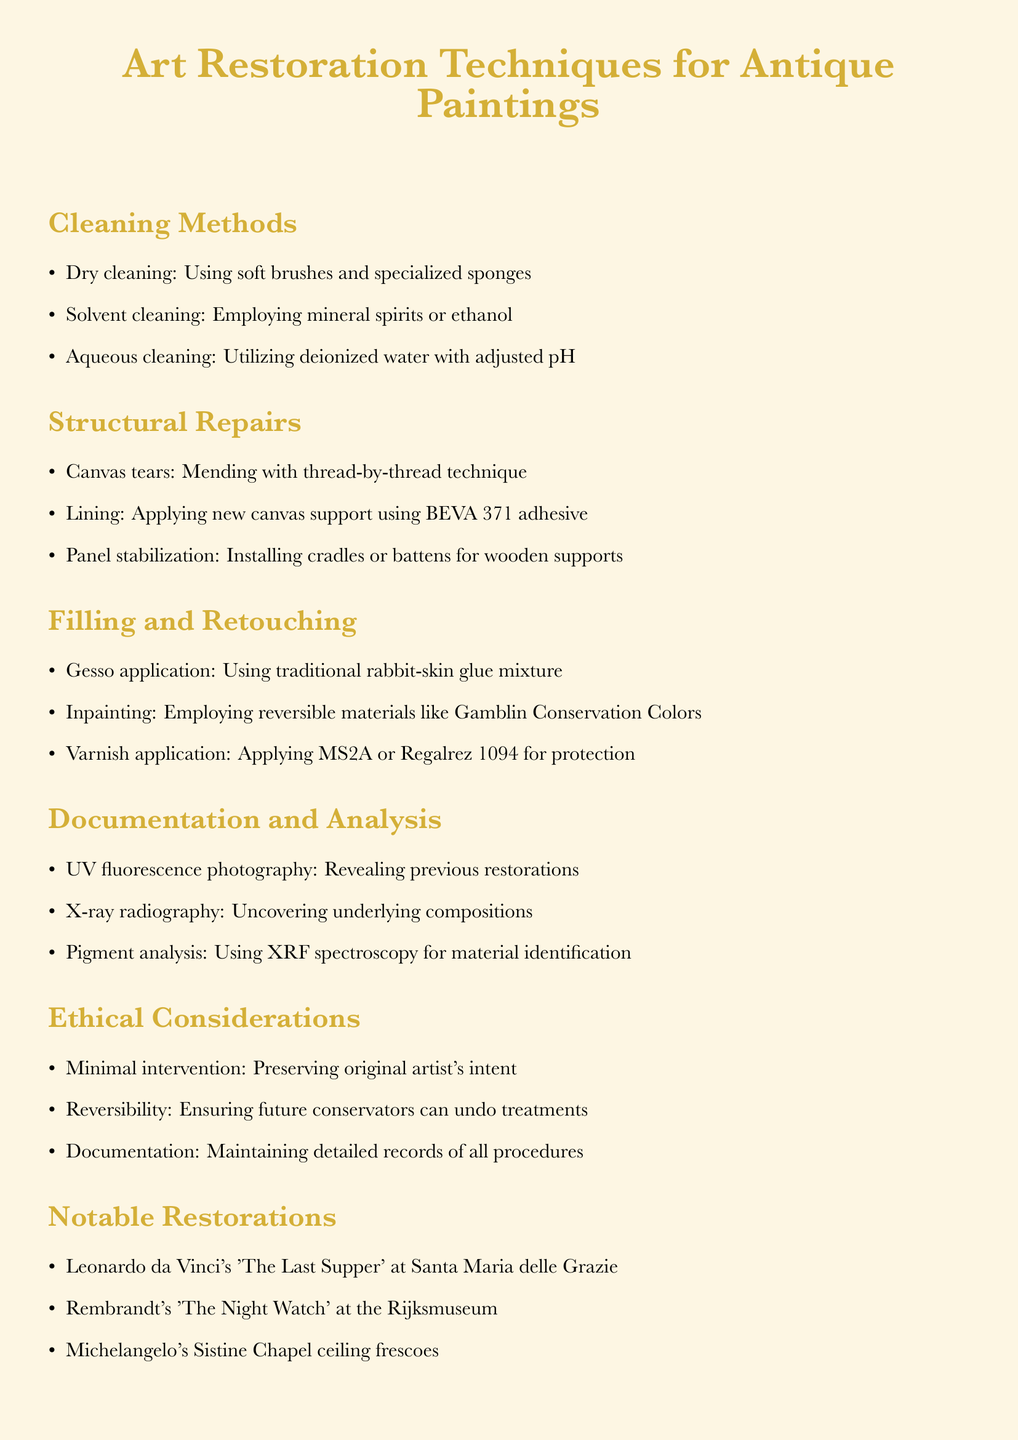What are the three cleaning methods mentioned? The document lists three cleaning methods, which are Dry cleaning, Solvent cleaning, and Aqueous cleaning.
Answer: Dry cleaning, Solvent cleaning, Aqueous cleaning What is the technique used for mending canvas tears? The document specifies that a thread-by-thread technique is used for mending canvas tears.
Answer: Thread-by-thread technique What materials are suggested for inpainting? The document mentions the use of reversible materials like Gamblin Conservation Colors for inpainting.
Answer: Gamblin Conservation Colors What is emphasized under ethical considerations regarding restoration? The document stresses minimal intervention as a key ethical consideration in art restoration.
Answer: Minimal intervention Which artist's work is noted for restoration at the Rijksmuseum? The document states that Rembrandt's 'The Night Watch' was restored at the Rijksmuseum.
Answer: Rembrandt's 'The Night Watch' 